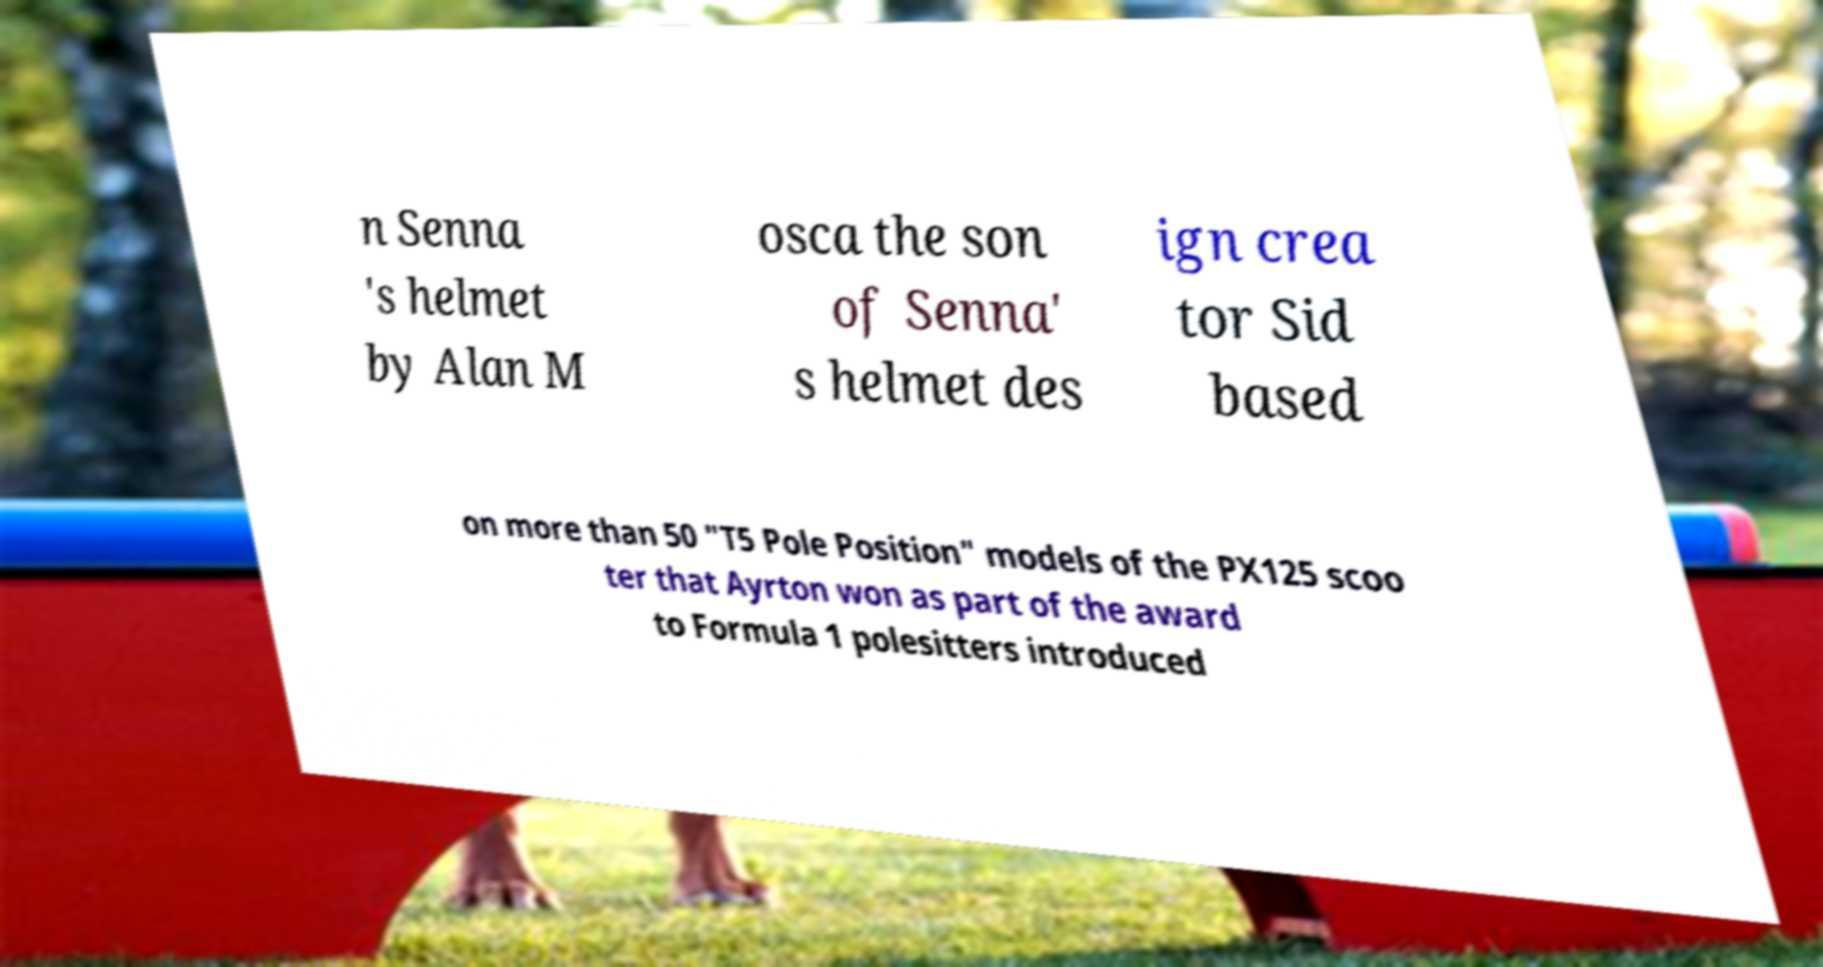Could you assist in decoding the text presented in this image and type it out clearly? n Senna 's helmet by Alan M osca the son of Senna' s helmet des ign crea tor Sid based on more than 50 "T5 Pole Position" models of the PX125 scoo ter that Ayrton won as part of the award to Formula 1 polesitters introduced 